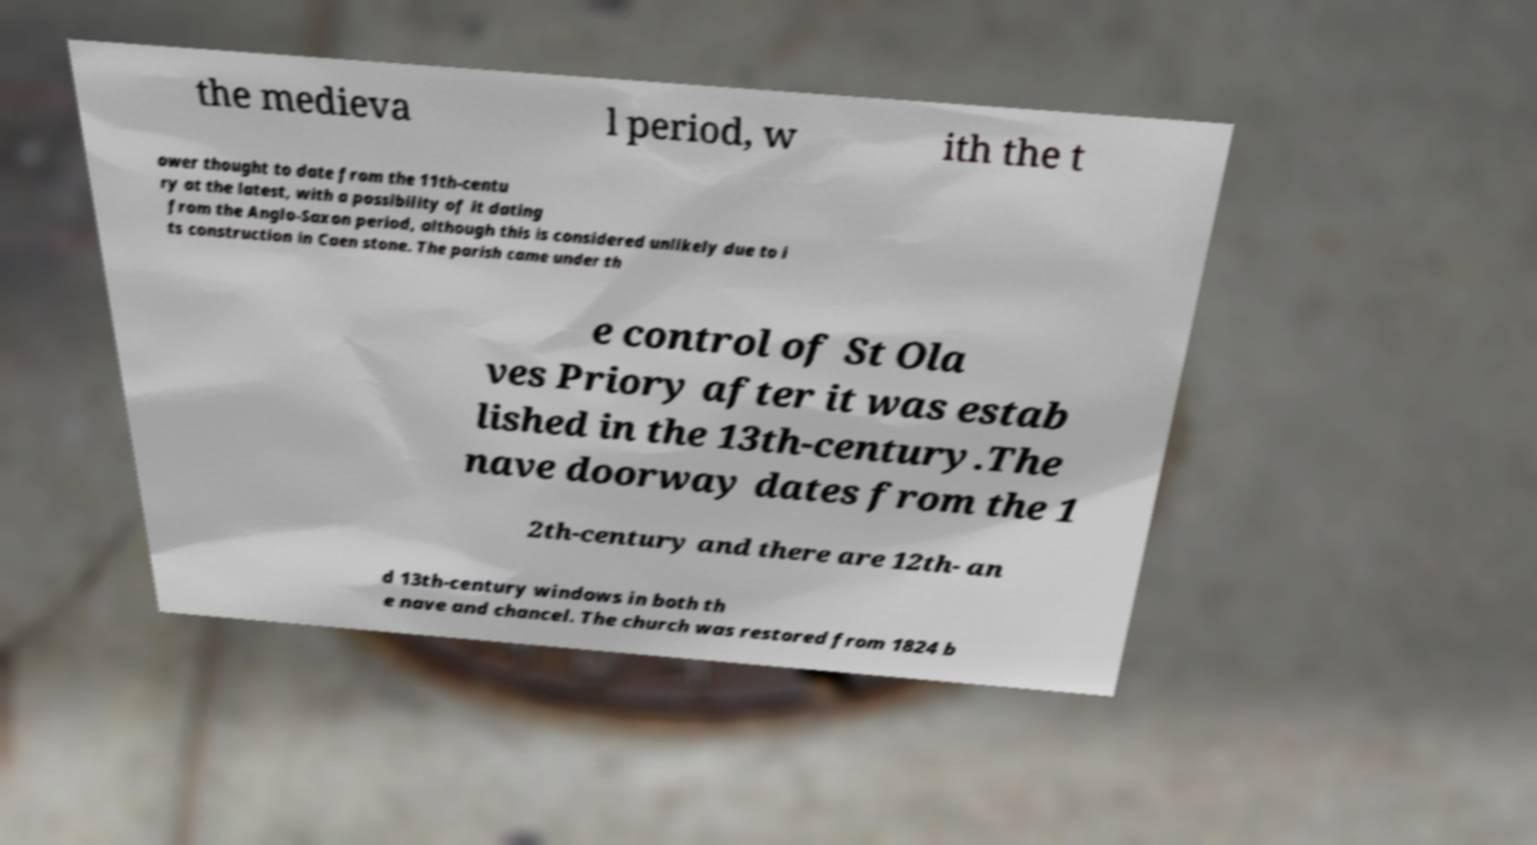Please identify and transcribe the text found in this image. the medieva l period, w ith the t ower thought to date from the 11th-centu ry at the latest, with a possibility of it dating from the Anglo-Saxon period, although this is considered unlikely due to i ts construction in Caen stone. The parish came under th e control of St Ola ves Priory after it was estab lished in the 13th-century.The nave doorway dates from the 1 2th-century and there are 12th- an d 13th-century windows in both th e nave and chancel. The church was restored from 1824 b 